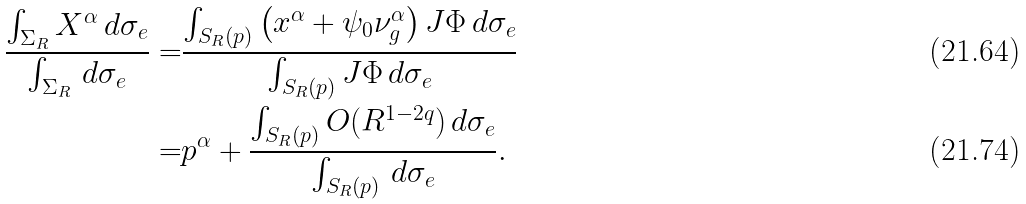Convert formula to latex. <formula><loc_0><loc_0><loc_500><loc_500>\frac { \int _ { \Sigma _ { R } } X ^ { \alpha } \, d \sigma _ { e } } { \int _ { \Sigma _ { R } } \, d \sigma _ { e } } = & \frac { \int _ { S _ { R } ( p ) } \left ( x ^ { \alpha } + \psi _ { 0 } \nu _ { g } ^ { \alpha } \right ) J \Phi \, d \sigma _ { e } } { \int _ { S _ { R } ( p ) } J \Phi \, d \sigma _ { e } } \\ = & p ^ { \alpha } + \frac { \int _ { S _ { R } ( p ) } O ( R ^ { 1 - 2 q } ) \, d \sigma _ { e } } { \int _ { S _ { R } ( p ) } \, d \sigma _ { e } } .</formula> 